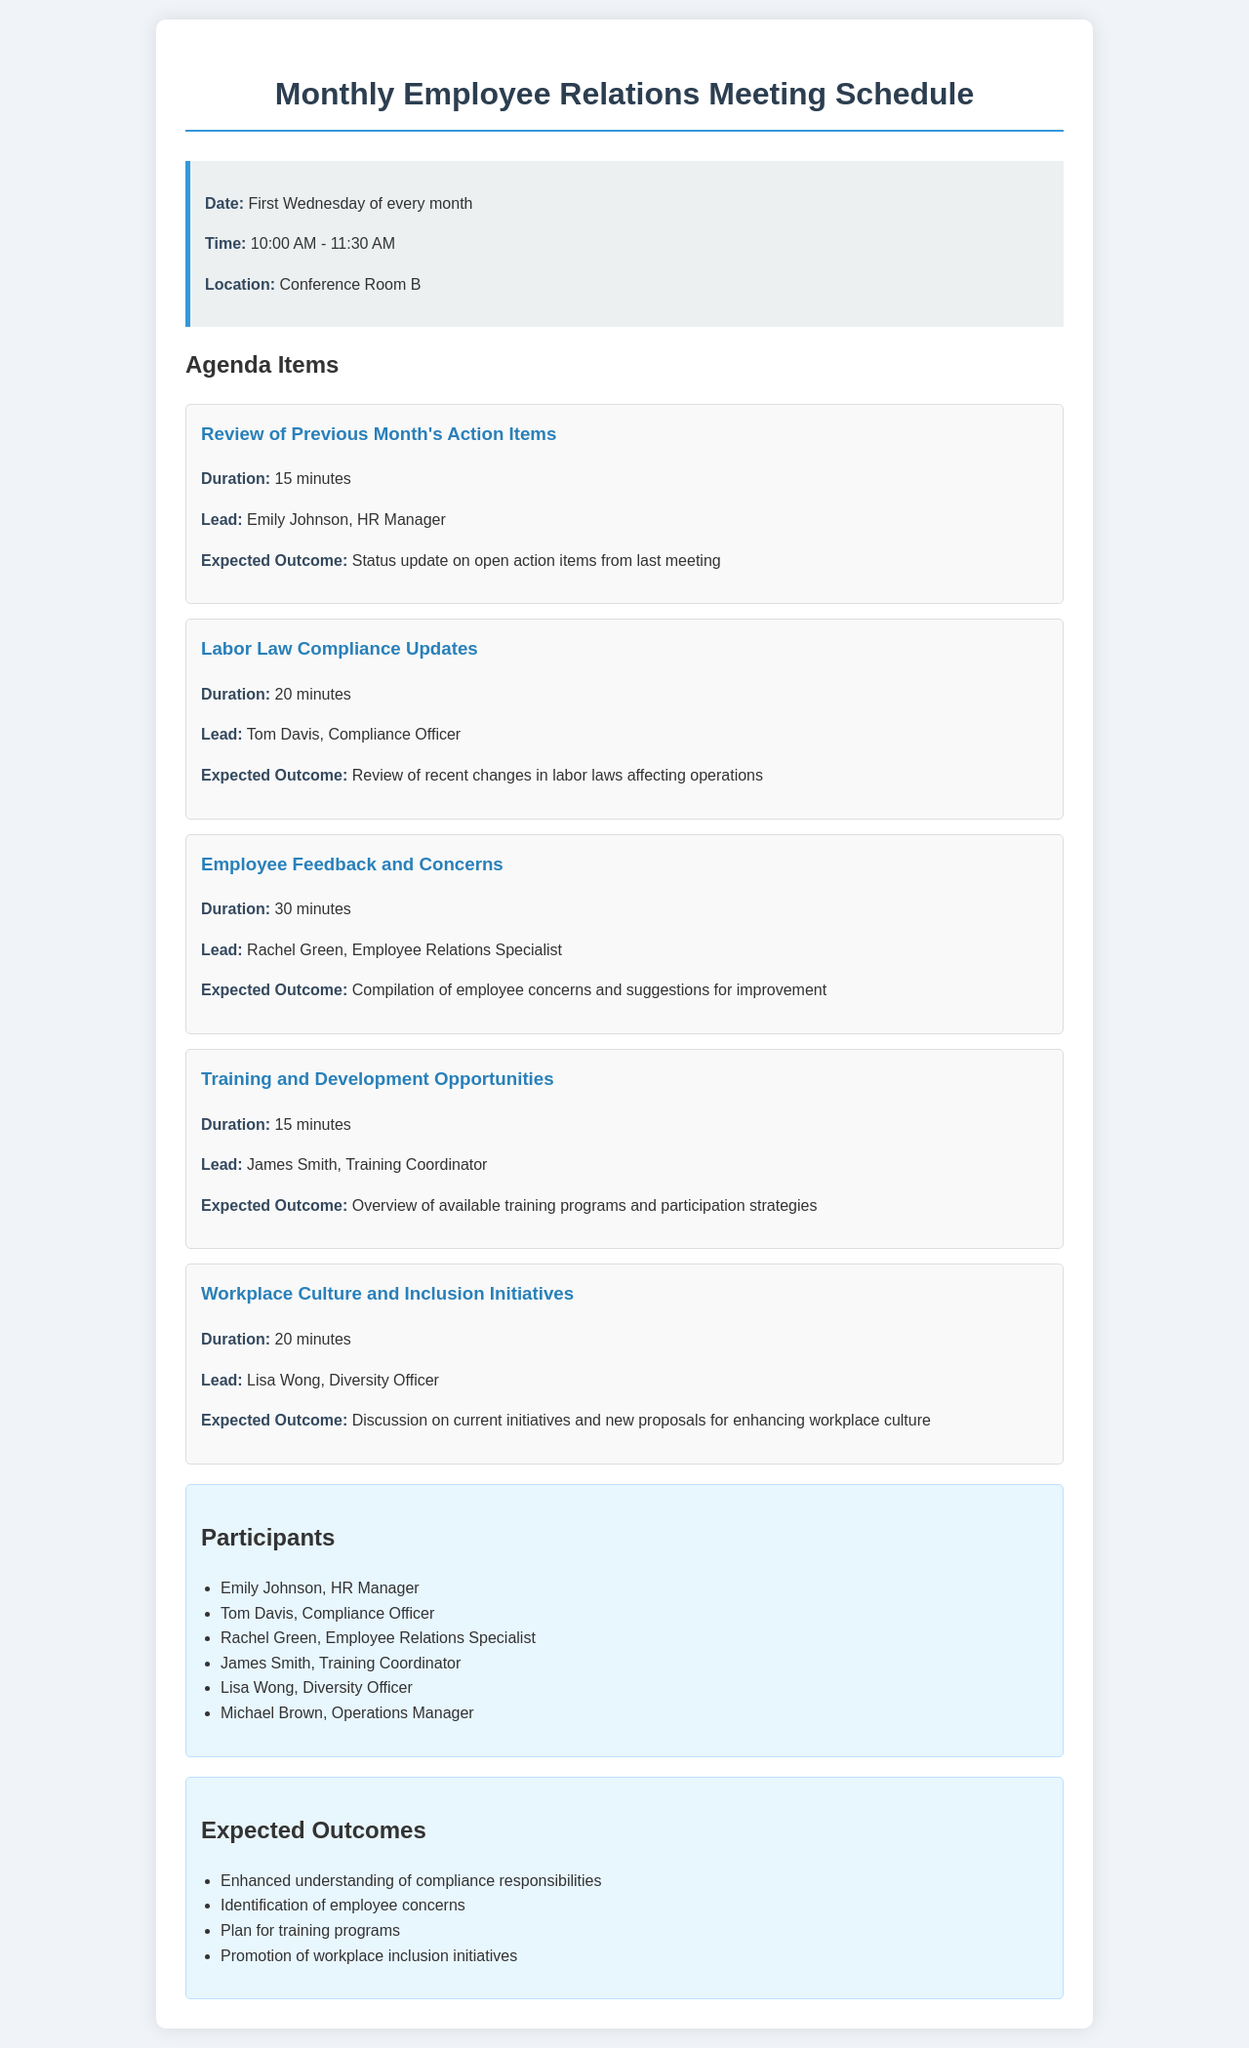what is the date of the meeting? The meeting is scheduled for the first Wednesday of every month.
Answer: First Wednesday of every month what is the duration of the Labor Law Compliance Updates agenda item? The duration for this agenda item is specifically mentioned in the document as 20 minutes.
Answer: 20 minutes who leads the Employee Feedback and Concerns agenda item? The document states that Rachel Green, Employee Relations Specialist, is the lead for this item.
Answer: Rachel Green, Employee Relations Specialist how many participants are listed in the document? The document provides a list of participants which includes six names.
Answer: 6 what is one expected outcome of the meeting? The document mentions several expected outcomes; one is enhanced understanding of compliance responsibilities.
Answer: Enhanced understanding of compliance responsibilities which role is responsible for Training and Development Opportunities? According to the document, James Smith, the Training Coordinator, leads this agenda item.
Answer: James Smith, Training Coordinator what time does the meeting start? The document specifies that the meeting starts at 10:00 AM.
Answer: 10:00 AM how many minutes are allocated for the Review of Previous Month's Action Items? The document indicates that this agenda item is allocated 15 minutes.
Answer: 15 minutes what is the location of the meeting? The location where the meeting will take place is specified in the document as Conference Room B.
Answer: Conference Room B 